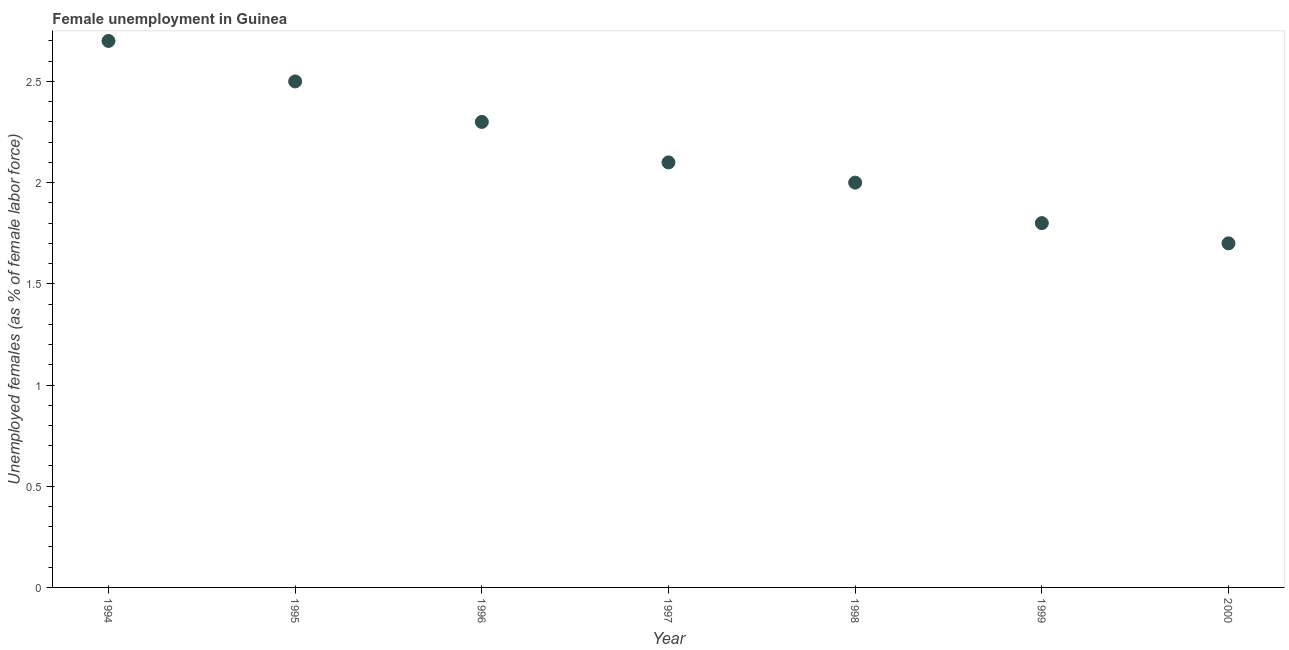What is the unemployed females population in 1995?
Give a very brief answer. 2.5. Across all years, what is the maximum unemployed females population?
Give a very brief answer. 2.7. Across all years, what is the minimum unemployed females population?
Keep it short and to the point. 1.7. What is the sum of the unemployed females population?
Offer a terse response. 15.1. What is the difference between the unemployed females population in 1994 and 1999?
Make the answer very short. 0.9. What is the average unemployed females population per year?
Your answer should be very brief. 2.16. What is the median unemployed females population?
Provide a succinct answer. 2.1. Do a majority of the years between 2000 and 1995 (inclusive) have unemployed females population greater than 2 %?
Make the answer very short. Yes. What is the ratio of the unemployed females population in 1998 to that in 2000?
Make the answer very short. 1.18. What is the difference between the highest and the second highest unemployed females population?
Give a very brief answer. 0.2. What is the difference between the highest and the lowest unemployed females population?
Ensure brevity in your answer.  1. In how many years, is the unemployed females population greater than the average unemployed females population taken over all years?
Keep it short and to the point. 3. Does the unemployed females population monotonically increase over the years?
Ensure brevity in your answer.  No. How many years are there in the graph?
Make the answer very short. 7. Are the values on the major ticks of Y-axis written in scientific E-notation?
Offer a very short reply. No. Does the graph contain any zero values?
Your response must be concise. No. What is the title of the graph?
Offer a very short reply. Female unemployment in Guinea. What is the label or title of the Y-axis?
Offer a very short reply. Unemployed females (as % of female labor force). What is the Unemployed females (as % of female labor force) in 1994?
Offer a terse response. 2.7. What is the Unemployed females (as % of female labor force) in 1996?
Your answer should be compact. 2.3. What is the Unemployed females (as % of female labor force) in 1997?
Keep it short and to the point. 2.1. What is the Unemployed females (as % of female labor force) in 1998?
Your response must be concise. 2. What is the Unemployed females (as % of female labor force) in 1999?
Ensure brevity in your answer.  1.8. What is the Unemployed females (as % of female labor force) in 2000?
Your answer should be very brief. 1.7. What is the difference between the Unemployed females (as % of female labor force) in 1994 and 1996?
Your answer should be very brief. 0.4. What is the difference between the Unemployed females (as % of female labor force) in 1994 and 1997?
Your response must be concise. 0.6. What is the difference between the Unemployed females (as % of female labor force) in 1994 and 1998?
Provide a short and direct response. 0.7. What is the difference between the Unemployed females (as % of female labor force) in 1994 and 1999?
Give a very brief answer. 0.9. What is the difference between the Unemployed females (as % of female labor force) in 1994 and 2000?
Ensure brevity in your answer.  1. What is the difference between the Unemployed females (as % of female labor force) in 1995 and 1997?
Your answer should be compact. 0.4. What is the difference between the Unemployed females (as % of female labor force) in 1995 and 1999?
Ensure brevity in your answer.  0.7. What is the difference between the Unemployed females (as % of female labor force) in 1996 and 1998?
Your response must be concise. 0.3. What is the difference between the Unemployed females (as % of female labor force) in 1996 and 2000?
Offer a very short reply. 0.6. What is the difference between the Unemployed females (as % of female labor force) in 1997 and 1999?
Provide a short and direct response. 0.3. What is the difference between the Unemployed females (as % of female labor force) in 1997 and 2000?
Keep it short and to the point. 0.4. What is the difference between the Unemployed females (as % of female labor force) in 1998 and 1999?
Keep it short and to the point. 0.2. What is the difference between the Unemployed females (as % of female labor force) in 1998 and 2000?
Offer a very short reply. 0.3. What is the difference between the Unemployed females (as % of female labor force) in 1999 and 2000?
Keep it short and to the point. 0.1. What is the ratio of the Unemployed females (as % of female labor force) in 1994 to that in 1995?
Offer a very short reply. 1.08. What is the ratio of the Unemployed females (as % of female labor force) in 1994 to that in 1996?
Offer a very short reply. 1.17. What is the ratio of the Unemployed females (as % of female labor force) in 1994 to that in 1997?
Offer a terse response. 1.29. What is the ratio of the Unemployed females (as % of female labor force) in 1994 to that in 1998?
Offer a very short reply. 1.35. What is the ratio of the Unemployed females (as % of female labor force) in 1994 to that in 2000?
Keep it short and to the point. 1.59. What is the ratio of the Unemployed females (as % of female labor force) in 1995 to that in 1996?
Provide a succinct answer. 1.09. What is the ratio of the Unemployed females (as % of female labor force) in 1995 to that in 1997?
Provide a short and direct response. 1.19. What is the ratio of the Unemployed females (as % of female labor force) in 1995 to that in 1998?
Ensure brevity in your answer.  1.25. What is the ratio of the Unemployed females (as % of female labor force) in 1995 to that in 1999?
Your response must be concise. 1.39. What is the ratio of the Unemployed females (as % of female labor force) in 1995 to that in 2000?
Keep it short and to the point. 1.47. What is the ratio of the Unemployed females (as % of female labor force) in 1996 to that in 1997?
Provide a short and direct response. 1.09. What is the ratio of the Unemployed females (as % of female labor force) in 1996 to that in 1998?
Keep it short and to the point. 1.15. What is the ratio of the Unemployed females (as % of female labor force) in 1996 to that in 1999?
Offer a very short reply. 1.28. What is the ratio of the Unemployed females (as % of female labor force) in 1996 to that in 2000?
Your response must be concise. 1.35. What is the ratio of the Unemployed females (as % of female labor force) in 1997 to that in 1998?
Provide a succinct answer. 1.05. What is the ratio of the Unemployed females (as % of female labor force) in 1997 to that in 1999?
Provide a short and direct response. 1.17. What is the ratio of the Unemployed females (as % of female labor force) in 1997 to that in 2000?
Your answer should be compact. 1.24. What is the ratio of the Unemployed females (as % of female labor force) in 1998 to that in 1999?
Provide a short and direct response. 1.11. What is the ratio of the Unemployed females (as % of female labor force) in 1998 to that in 2000?
Keep it short and to the point. 1.18. What is the ratio of the Unemployed females (as % of female labor force) in 1999 to that in 2000?
Keep it short and to the point. 1.06. 